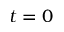Convert formula to latex. <formula><loc_0><loc_0><loc_500><loc_500>t = 0</formula> 